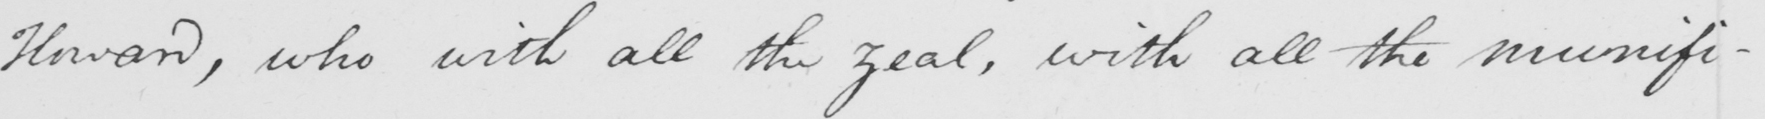What does this handwritten line say? Howard , who with all the zeal , with all the munifi- 